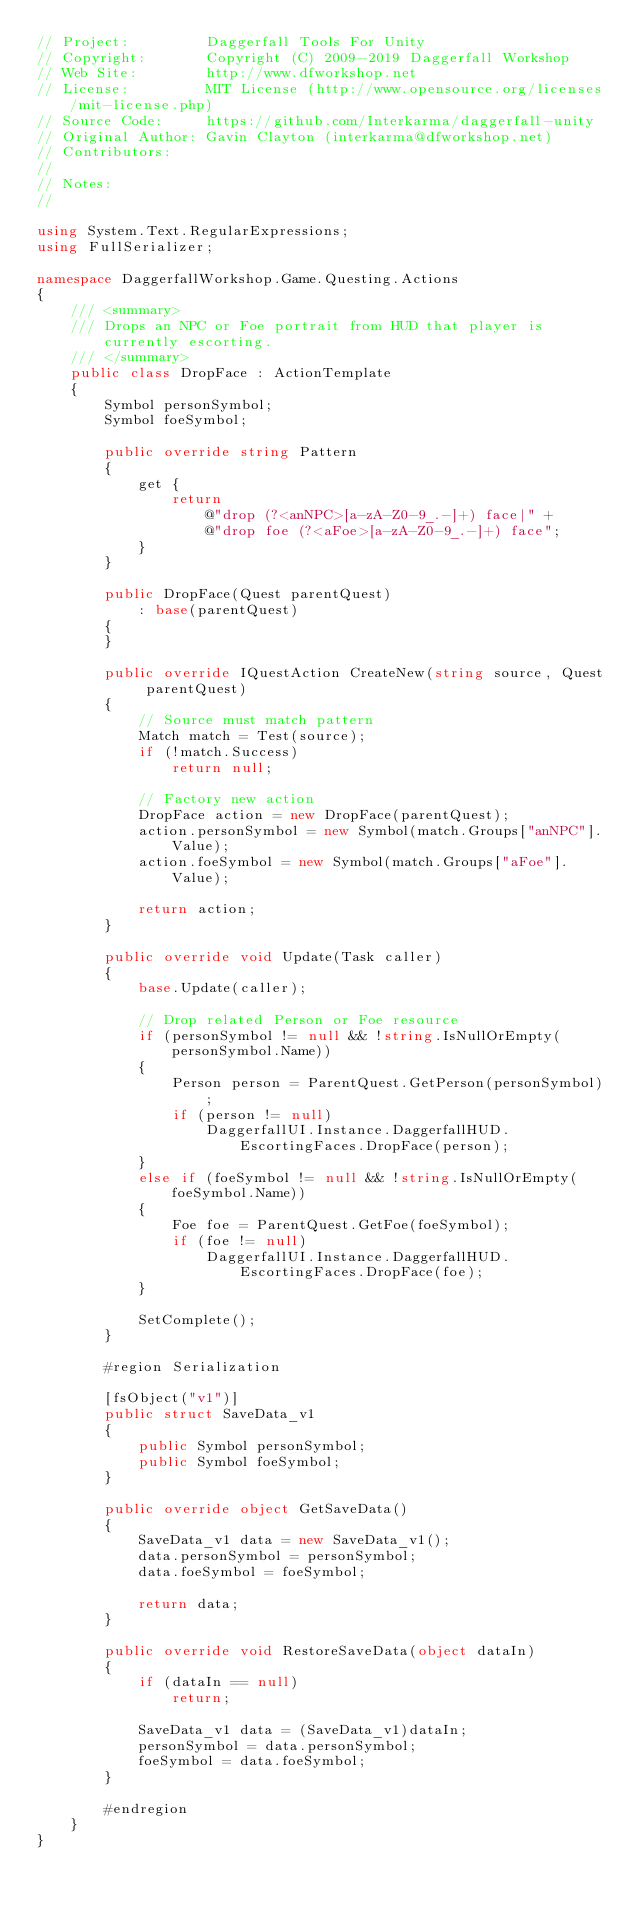<code> <loc_0><loc_0><loc_500><loc_500><_C#_>// Project:         Daggerfall Tools For Unity
// Copyright:       Copyright (C) 2009-2019 Daggerfall Workshop
// Web Site:        http://www.dfworkshop.net
// License:         MIT License (http://www.opensource.org/licenses/mit-license.php)
// Source Code:     https://github.com/Interkarma/daggerfall-unity
// Original Author: Gavin Clayton (interkarma@dfworkshop.net)
// Contributors:    
// 
// Notes:
//

using System.Text.RegularExpressions;
using FullSerializer;

namespace DaggerfallWorkshop.Game.Questing.Actions
{
    /// <summary>
    /// Drops an NPC or Foe portrait from HUD that player is currently escorting.
    /// </summary>
    public class DropFace : ActionTemplate
    {
        Symbol personSymbol;
        Symbol foeSymbol;

        public override string Pattern
        {
            get {
                return
                    @"drop (?<anNPC>[a-zA-Z0-9_.-]+) face|" +
                    @"drop foe (?<aFoe>[a-zA-Z0-9_.-]+) face";
            }
        }

        public DropFace(Quest parentQuest)
            : base(parentQuest)
        {
        }

        public override IQuestAction CreateNew(string source, Quest parentQuest)
        {
            // Source must match pattern
            Match match = Test(source);
            if (!match.Success)
                return null;

            // Factory new action
            DropFace action = new DropFace(parentQuest);
            action.personSymbol = new Symbol(match.Groups["anNPC"].Value);
            action.foeSymbol = new Symbol(match.Groups["aFoe"].Value);

            return action;
        }

        public override void Update(Task caller)
        {
            base.Update(caller);

            // Drop related Person or Foe resource
            if (personSymbol != null && !string.IsNullOrEmpty(personSymbol.Name))
            {
                Person person = ParentQuest.GetPerson(personSymbol);
                if (person != null)
                    DaggerfallUI.Instance.DaggerfallHUD.EscortingFaces.DropFace(person);
            }
            else if (foeSymbol != null && !string.IsNullOrEmpty(foeSymbol.Name))
            {
                Foe foe = ParentQuest.GetFoe(foeSymbol);
                if (foe != null)
                    DaggerfallUI.Instance.DaggerfallHUD.EscortingFaces.DropFace(foe);
            }

            SetComplete();
        }

        #region Serialization

        [fsObject("v1")]
        public struct SaveData_v1
        {
            public Symbol personSymbol;
            public Symbol foeSymbol;
        }

        public override object GetSaveData()
        {
            SaveData_v1 data = new SaveData_v1();
            data.personSymbol = personSymbol;
            data.foeSymbol = foeSymbol;

            return data;
        }

        public override void RestoreSaveData(object dataIn)
        {
            if (dataIn == null)
                return;

            SaveData_v1 data = (SaveData_v1)dataIn;
            personSymbol = data.personSymbol;
            foeSymbol = data.foeSymbol;
        }

        #endregion
    }
}</code> 